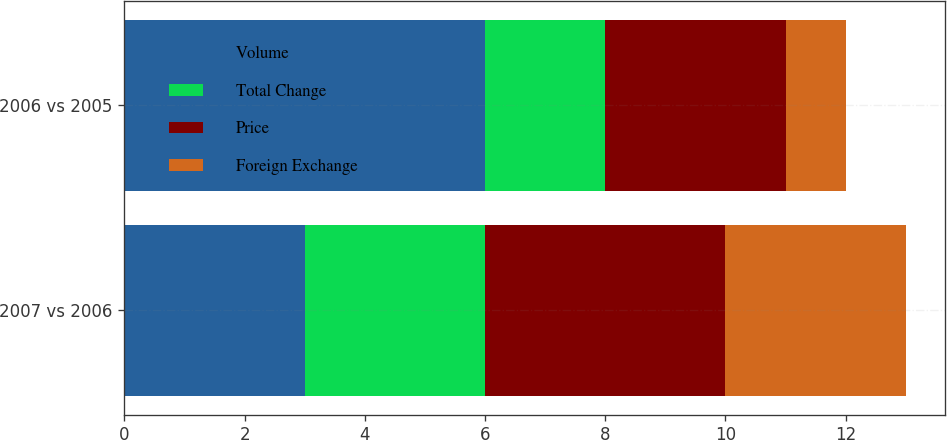Convert chart to OTSL. <chart><loc_0><loc_0><loc_500><loc_500><stacked_bar_chart><ecel><fcel>2007 vs 2006<fcel>2006 vs 2005<nl><fcel>Volume<fcel>3<fcel>6<nl><fcel>Total Change<fcel>3<fcel>2<nl><fcel>Price<fcel>4<fcel>3<nl><fcel>Foreign Exchange<fcel>3<fcel>1<nl></chart> 